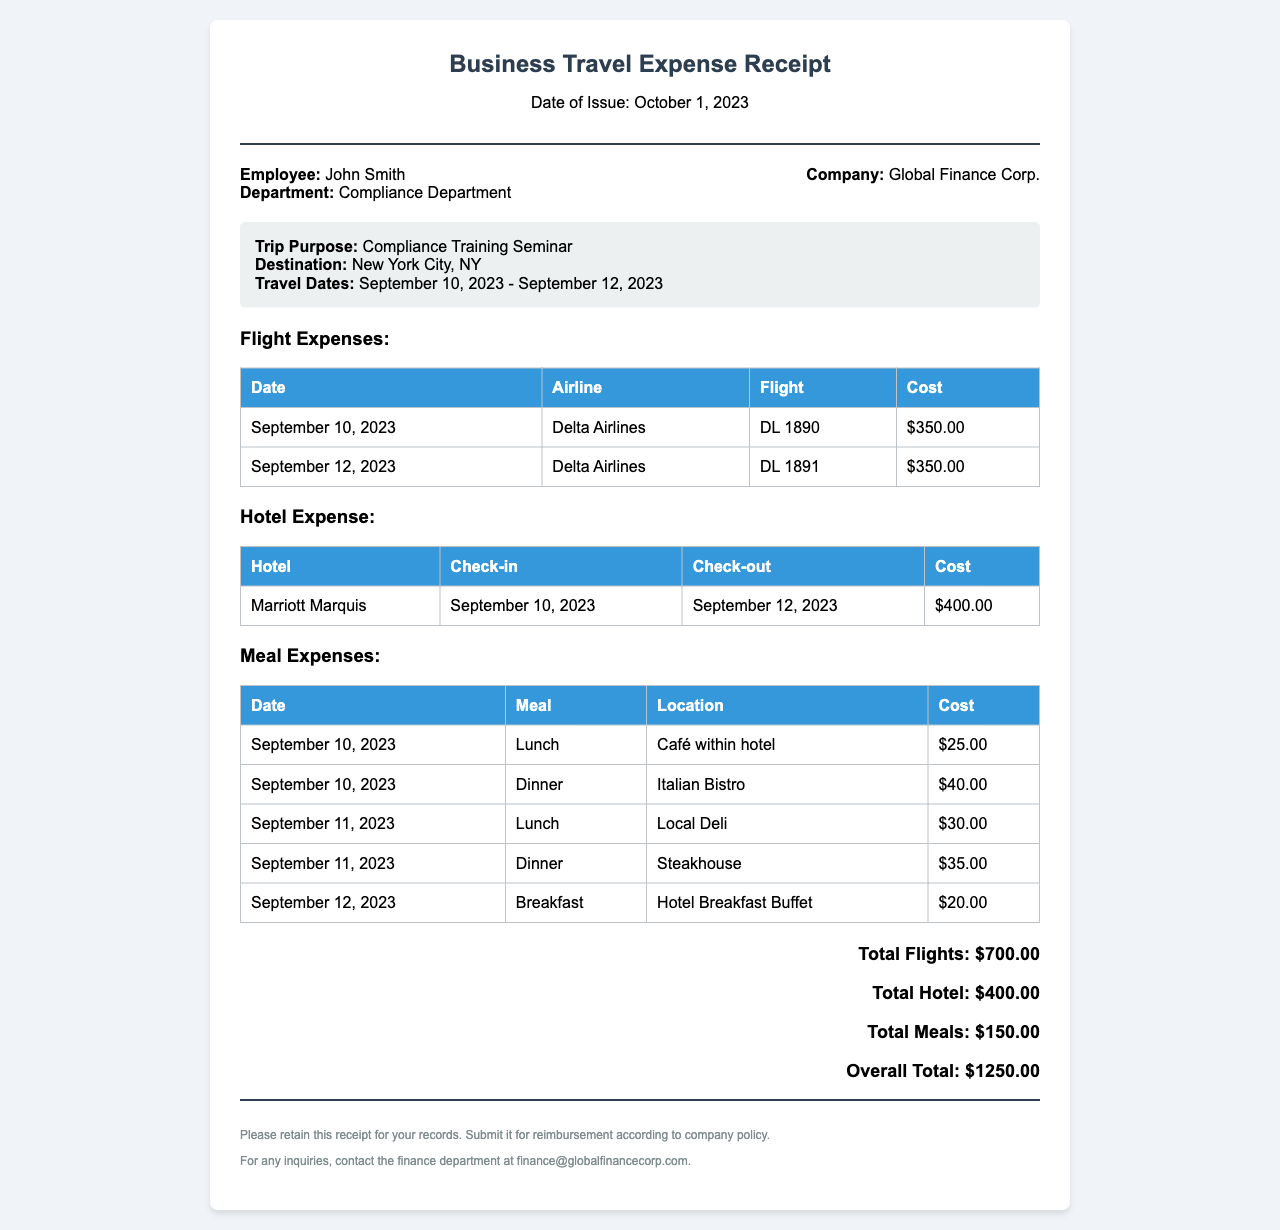What is the purpose of the trip? The purpose of the trip is specified in the document as "Compliance Training Seminar."
Answer: Compliance Training Seminar What is the total cost of the hotel stay? The total cost for the hotel stay is listed in the expenses section, which is $400.00.
Answer: $400.00 When was the employee's trip? The travel dates are given as September 10, 2023 - September 12, 2023.
Answer: September 10, 2023 - September 12, 2023 How many meals were listed in the receipt? The document lists five meal entries under Meal Expenses, detailing each meal separately.
Answer: Five What is the total flight cost? The total cost for flights is summed up in the document as $700.00 from the two flight entries.
Answer: $700.00 Who is the employee? The employee's name is presented in the document as "John Smith."
Answer: John Smith Which hotel was used during the trip? The document specifies the hotel as "Marriott Marquis."
Answer: Marriott Marquis What airline was used for the flights? The only airline mentioned in the flight expenses is "Delta Airlines."
Answer: Delta Airlines What was the check-out date from the hotel? The check-out date listed in the hotel expense table is September 12, 2023.
Answer: September 12, 2023 